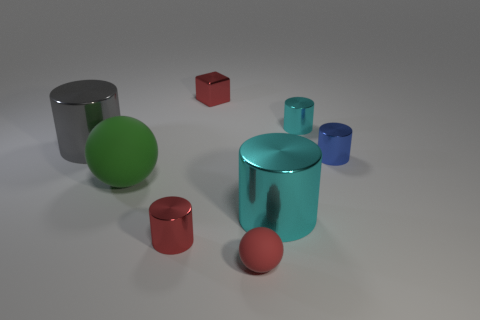Are there any objects that have similar shapes in the image? Yes, there are two pairs of objects with similar shapes: two cylinders and two cubes, although they differ in size and color. What role does color play in distinguishing these objects? Color is an essential aspect of the image that differentiates each object. It gives each shape a unique identity, making it easier to visually separate them and appreciate their individuality in the composition. 